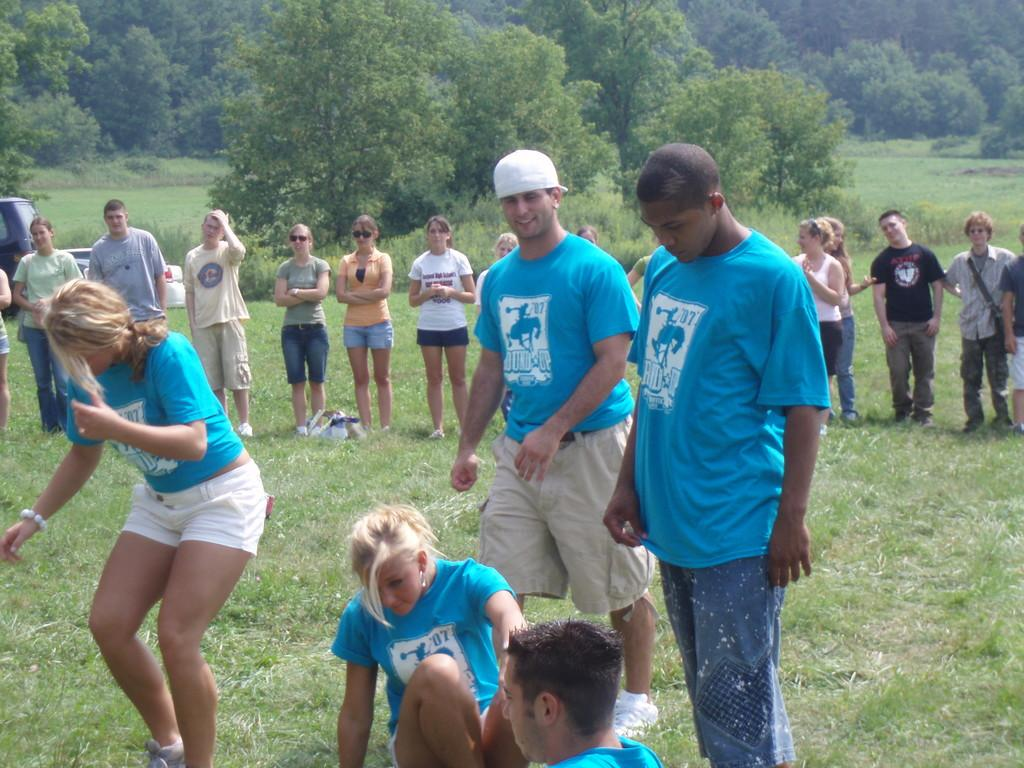How many people are present in the image? There are five persons in the image. What are the persons in the image doing? The persons are doing some activity. Can you describe the background of the image? There are people standing in the background of the image, and there are trees as well. What type of mark can be seen on the wall in the room? There is no mention of a room or a mark on the wall in the provided facts, so we cannot answer this question based on the image. 